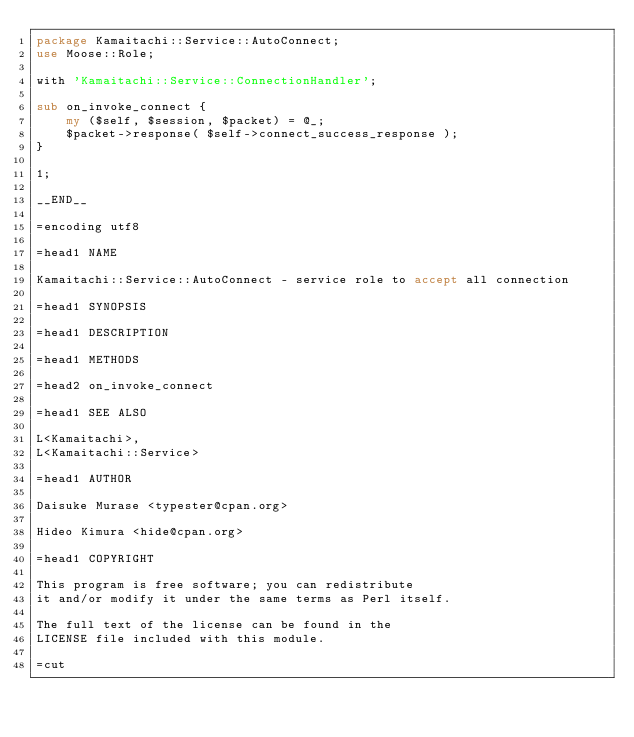Convert code to text. <code><loc_0><loc_0><loc_500><loc_500><_Perl_>package Kamaitachi::Service::AutoConnect;
use Moose::Role;

with 'Kamaitachi::Service::ConnectionHandler';

sub on_invoke_connect {
    my ($self, $session, $packet) = @_;
    $packet->response( $self->connect_success_response );
}

1;

__END__

=encoding utf8

=head1 NAME

Kamaitachi::Service::AutoConnect - service role to accept all connection

=head1 SYNOPSIS

=head1 DESCRIPTION

=head1 METHODS

=head2 on_invoke_connect

=head1 SEE ALSO

L<Kamaitachi>,
L<Kamaitachi::Service>

=head1 AUTHOR

Daisuke Murase <typester@cpan.org>

Hideo Kimura <hide@cpan.org>

=head1 COPYRIGHT

This program is free software; you can redistribute
it and/or modify it under the same terms as Perl itself.

The full text of the license can be found in the
LICENSE file included with this module.

=cut
</code> 